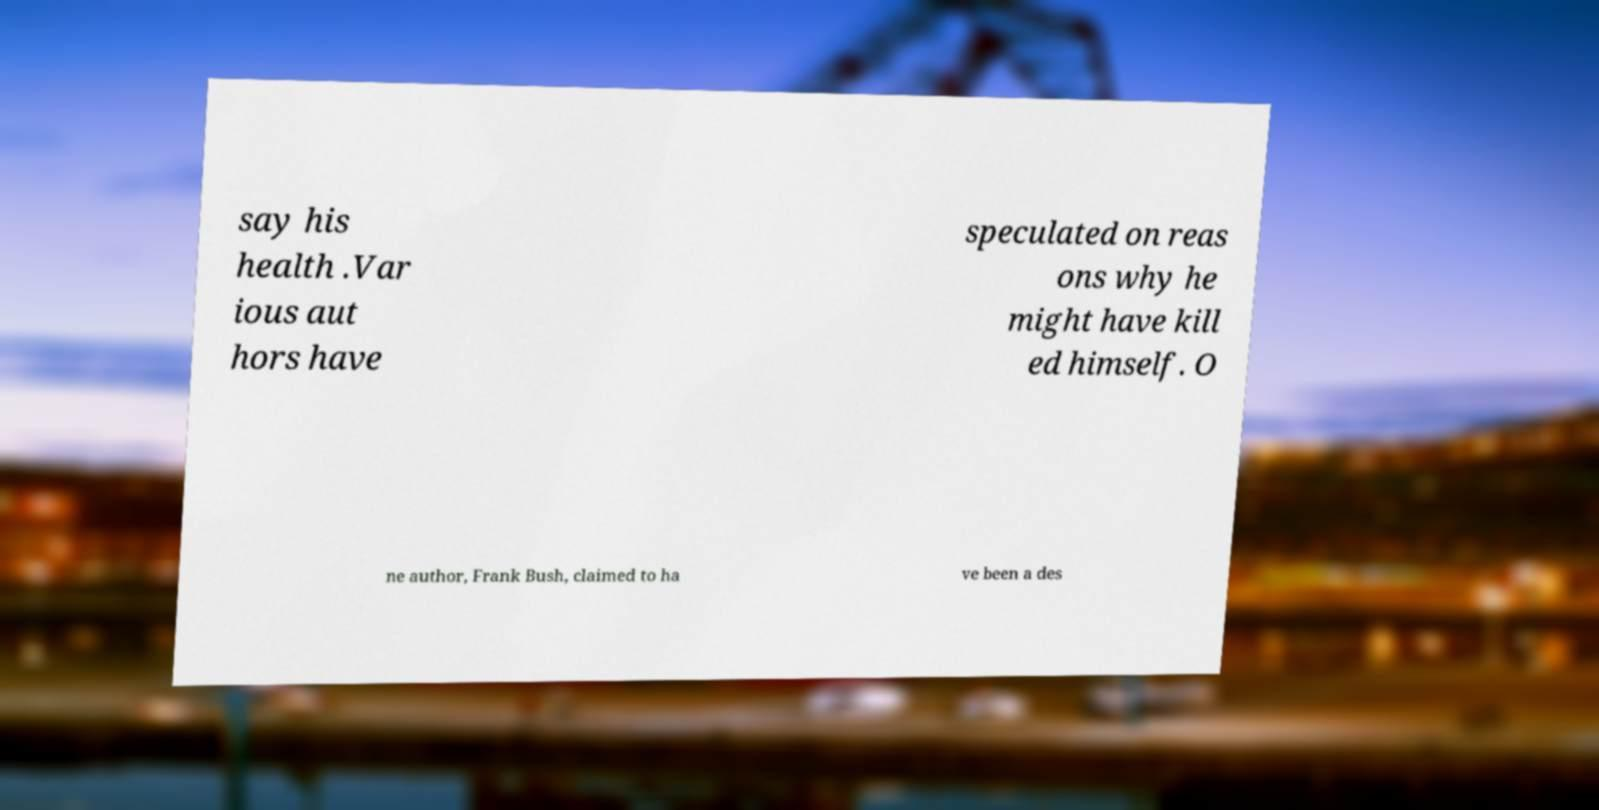I need the written content from this picture converted into text. Can you do that? say his health .Var ious aut hors have speculated on reas ons why he might have kill ed himself. O ne author, Frank Bush, claimed to ha ve been a des 